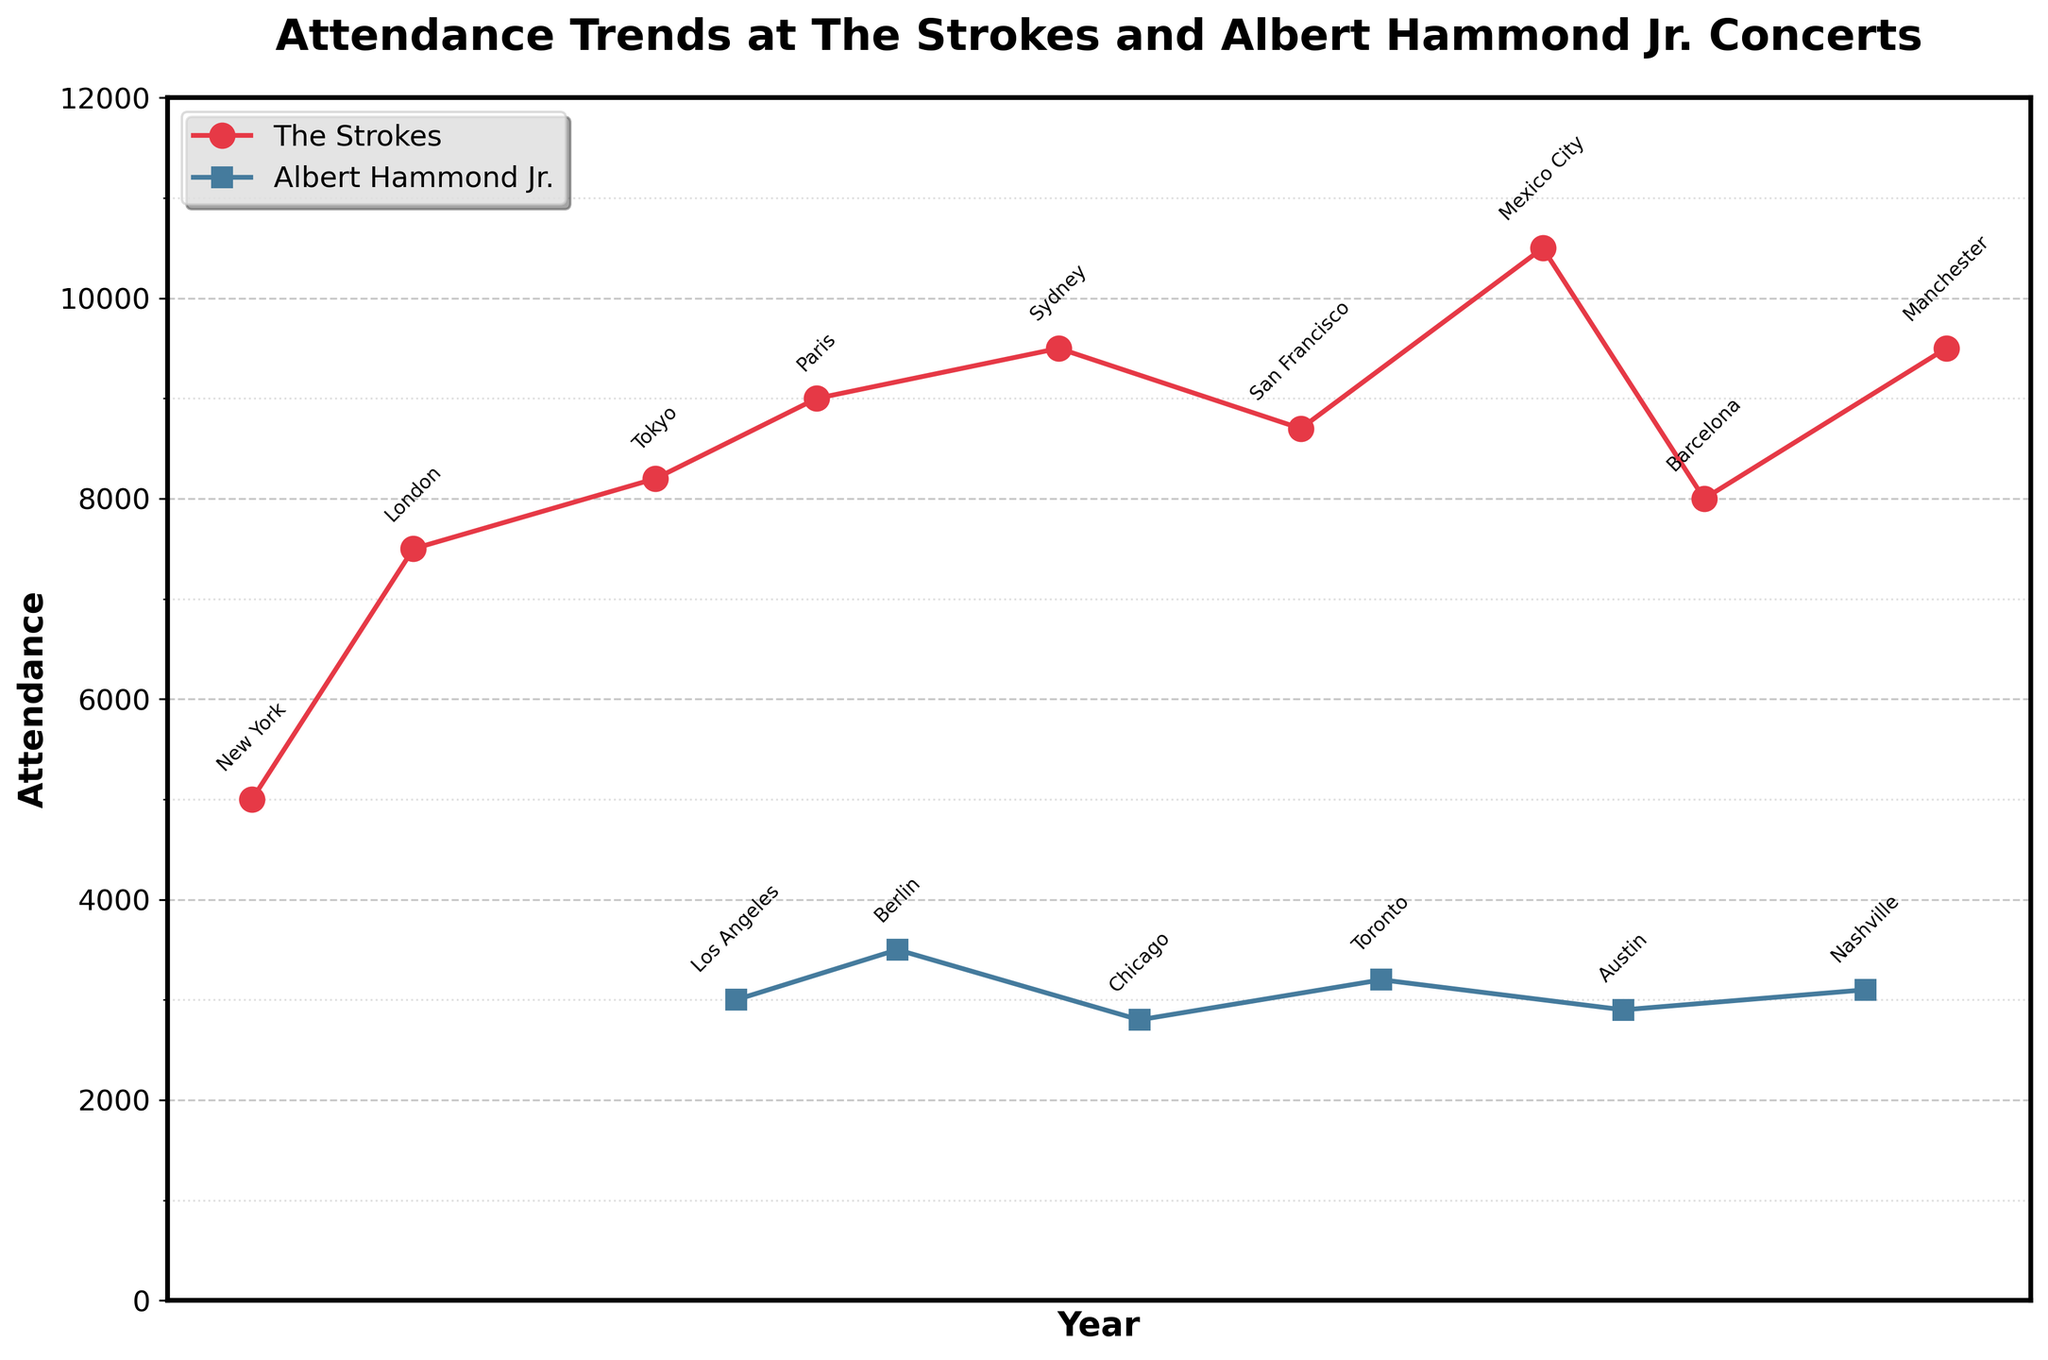What is the title of the plot? The title is written at the top of the plot, summarizing what the data represents. It says, "Attendance Trends at The Strokes and Albert Hammond Jr. Concerts".
Answer: Attendance Trends at The Strokes and Albert Hammond Jr. Concerts In which year did "The Strokes" have the highest attendance, according to the plot? Look at the red line representing "The Strokes" and identify the peak value. The highest point in the red line is in 2017, where the attendance is 10500.
Answer: 2017 Which event had an attendance of 3100 in 2021? Focus on the blue line representing "Albert Hammond Jr." and locate the data point for the year 2021. The label next to the point indicates it is "Albert Hammond Jr." with an attendance of 3100.
Answer: Albert Hammond Jr How does the attendance of "The Strokes" in 2008 compare to their attendance in 2014? Compare the values on the red line for the years 2008 and 2014. In 2008, the attendance is 9000, and in 2014, it is 8700. So, the attendance in 2008 is higher.
Answer: Higher in 2008 What is the average attendance of "Albert Hammond Jr." concerts over the years? Calculate the average by adding all attendance figures for "Albert Hammond Jr." and dividing by the number of events. (3000 + 3500 + 2800 + 3200 + 2900 + 3100) / 6 = 18500 / 6 ≈ 3083.33
Answer: 3083.33 How many events had an attendance greater than 8000? Count the data points with an attendance value above 8000 on both red and blue lines. The events in 2006, 2008, 2011, 2014, 2017, 2019, and 2022 have attendances greater than 8000, totaling 7 events.
Answer: 7 Which city hosted a concert with the highest attendance, and what was the exact number? Identify the peak attendance value and its label. The red line has the highest peak at 10500 labeled "Mexico City".
Answer: Mexico City, 10500 How did the attendance trend for "Albert Hammond Jr." concerts change from 2007 to 2021? Observe the pattern of data points on the blue line from 2007 to 2021. It starts at 3000, slightly increases, and shows fluctuations around 3000, ending at 3100 in 2021.
Answer: Fluctuated around 3000 In which year did "The Strokes" play in Barcelona, and what was the attendance? Look for the label "Barcelona" on the red line to find the year and attendance. In 2019, "The Strokes" played in Barcelona with an attendance of 8000.
Answer: 2019, 8000 